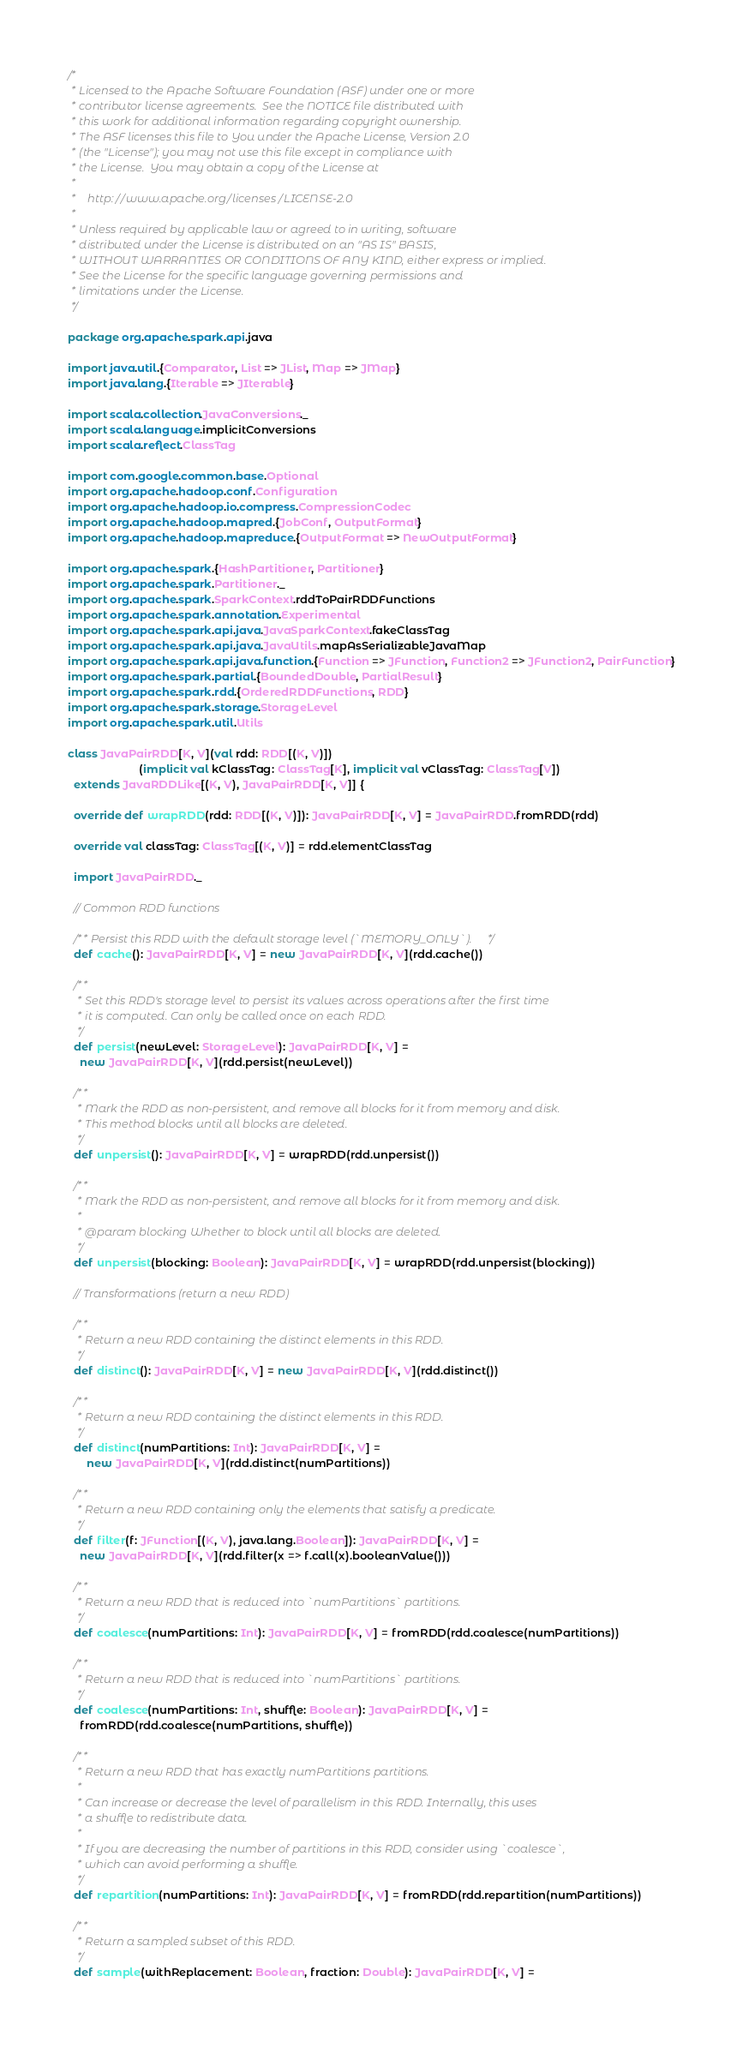<code> <loc_0><loc_0><loc_500><loc_500><_Scala_>/*
 * Licensed to the Apache Software Foundation (ASF) under one or more
 * contributor license agreements.  See the NOTICE file distributed with
 * this work for additional information regarding copyright ownership.
 * The ASF licenses this file to You under the Apache License, Version 2.0
 * (the "License"); you may not use this file except in compliance with
 * the License.  You may obtain a copy of the License at
 *
 *    http://www.apache.org/licenses/LICENSE-2.0
 *
 * Unless required by applicable law or agreed to in writing, software
 * distributed under the License is distributed on an "AS IS" BASIS,
 * WITHOUT WARRANTIES OR CONDITIONS OF ANY KIND, either express or implied.
 * See the License for the specific language governing permissions and
 * limitations under the License.
 */

package org.apache.spark.api.java

import java.util.{Comparator, List => JList, Map => JMap}
import java.lang.{Iterable => JIterable}

import scala.collection.JavaConversions._
import scala.language.implicitConversions
import scala.reflect.ClassTag

import com.google.common.base.Optional
import org.apache.hadoop.conf.Configuration
import org.apache.hadoop.io.compress.CompressionCodec
import org.apache.hadoop.mapred.{JobConf, OutputFormat}
import org.apache.hadoop.mapreduce.{OutputFormat => NewOutputFormat}

import org.apache.spark.{HashPartitioner, Partitioner}
import org.apache.spark.Partitioner._
import org.apache.spark.SparkContext.rddToPairRDDFunctions
import org.apache.spark.annotation.Experimental
import org.apache.spark.api.java.JavaSparkContext.fakeClassTag
import org.apache.spark.api.java.JavaUtils.mapAsSerializableJavaMap
import org.apache.spark.api.java.function.{Function => JFunction, Function2 => JFunction2, PairFunction}
import org.apache.spark.partial.{BoundedDouble, PartialResult}
import org.apache.spark.rdd.{OrderedRDDFunctions, RDD}
import org.apache.spark.storage.StorageLevel
import org.apache.spark.util.Utils

class JavaPairRDD[K, V](val rdd: RDD[(K, V)])
                       (implicit val kClassTag: ClassTag[K], implicit val vClassTag: ClassTag[V])
  extends JavaRDDLike[(K, V), JavaPairRDD[K, V]] {

  override def wrapRDD(rdd: RDD[(K, V)]): JavaPairRDD[K, V] = JavaPairRDD.fromRDD(rdd)

  override val classTag: ClassTag[(K, V)] = rdd.elementClassTag

  import JavaPairRDD._

  // Common RDD functions

  /** Persist this RDD with the default storage level (`MEMORY_ONLY`). */
  def cache(): JavaPairRDD[K, V] = new JavaPairRDD[K, V](rdd.cache())

  /**
   * Set this RDD's storage level to persist its values across operations after the first time
   * it is computed. Can only be called once on each RDD.
   */
  def persist(newLevel: StorageLevel): JavaPairRDD[K, V] =
    new JavaPairRDD[K, V](rdd.persist(newLevel))

  /**
   * Mark the RDD as non-persistent, and remove all blocks for it from memory and disk.
   * This method blocks until all blocks are deleted.
   */
  def unpersist(): JavaPairRDD[K, V] = wrapRDD(rdd.unpersist())

  /**
   * Mark the RDD as non-persistent, and remove all blocks for it from memory and disk.
   *
   * @param blocking Whether to block until all blocks are deleted.
   */
  def unpersist(blocking: Boolean): JavaPairRDD[K, V] = wrapRDD(rdd.unpersist(blocking))

  // Transformations (return a new RDD)

  /**
   * Return a new RDD containing the distinct elements in this RDD.
   */
  def distinct(): JavaPairRDD[K, V] = new JavaPairRDD[K, V](rdd.distinct())

  /**
   * Return a new RDD containing the distinct elements in this RDD.
   */
  def distinct(numPartitions: Int): JavaPairRDD[K, V] =
      new JavaPairRDD[K, V](rdd.distinct(numPartitions))

  /**
   * Return a new RDD containing only the elements that satisfy a predicate.
   */
  def filter(f: JFunction[(K, V), java.lang.Boolean]): JavaPairRDD[K, V] =
    new JavaPairRDD[K, V](rdd.filter(x => f.call(x).booleanValue()))

  /**
   * Return a new RDD that is reduced into `numPartitions` partitions.
   */
  def coalesce(numPartitions: Int): JavaPairRDD[K, V] = fromRDD(rdd.coalesce(numPartitions))

  /**
   * Return a new RDD that is reduced into `numPartitions` partitions.
   */
  def coalesce(numPartitions: Int, shuffle: Boolean): JavaPairRDD[K, V] =
    fromRDD(rdd.coalesce(numPartitions, shuffle))

  /**
   * Return a new RDD that has exactly numPartitions partitions.
   *
   * Can increase or decrease the level of parallelism in this RDD. Internally, this uses
   * a shuffle to redistribute data.
   *
   * If you are decreasing the number of partitions in this RDD, consider using `coalesce`,
   * which can avoid performing a shuffle.
   */
  def repartition(numPartitions: Int): JavaPairRDD[K, V] = fromRDD(rdd.repartition(numPartitions))

  /**
   * Return a sampled subset of this RDD.
   */
  def sample(withReplacement: Boolean, fraction: Double): JavaPairRDD[K, V] =</code> 